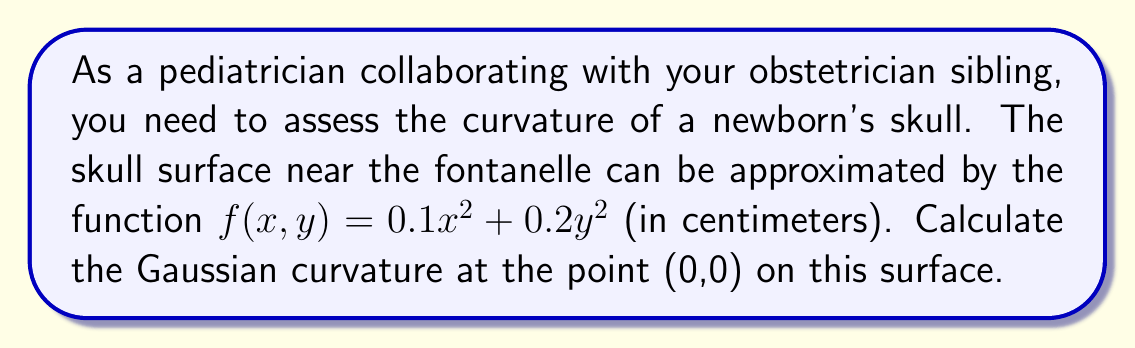Can you answer this question? To calculate the Gaussian curvature, we'll follow these steps:

1) The Gaussian curvature K is given by:
   $$K = \frac{f_{xx}f_{yy} - f_{xy}^2}{(1 + f_x^2 + f_y^2)^2}$$

2) Calculate the partial derivatives:
   $f_x = 0.2x$
   $f_y = 0.4y$
   $f_{xx} = 0.2$
   $f_{yy} = 0.4$
   $f_{xy} = 0$

3) At the point (0,0):
   $f_x(0,0) = 0$
   $f_y(0,0) = 0$
   $f_{xx}(0,0) = 0.2$
   $f_{yy}(0,0) = 0.4$
   $f_{xy}(0,0) = 0$

4) Substitute these values into the Gaussian curvature formula:
   $$K = \frac{0.2 \cdot 0.4 - 0^2}{(1 + 0^2 + 0^2)^2} = \frac{0.08}{1} = 0.08$$

5) Therefore, the Gaussian curvature at (0,0) is 0.08 cm^(-2).
Answer: 0.08 cm^(-2) 